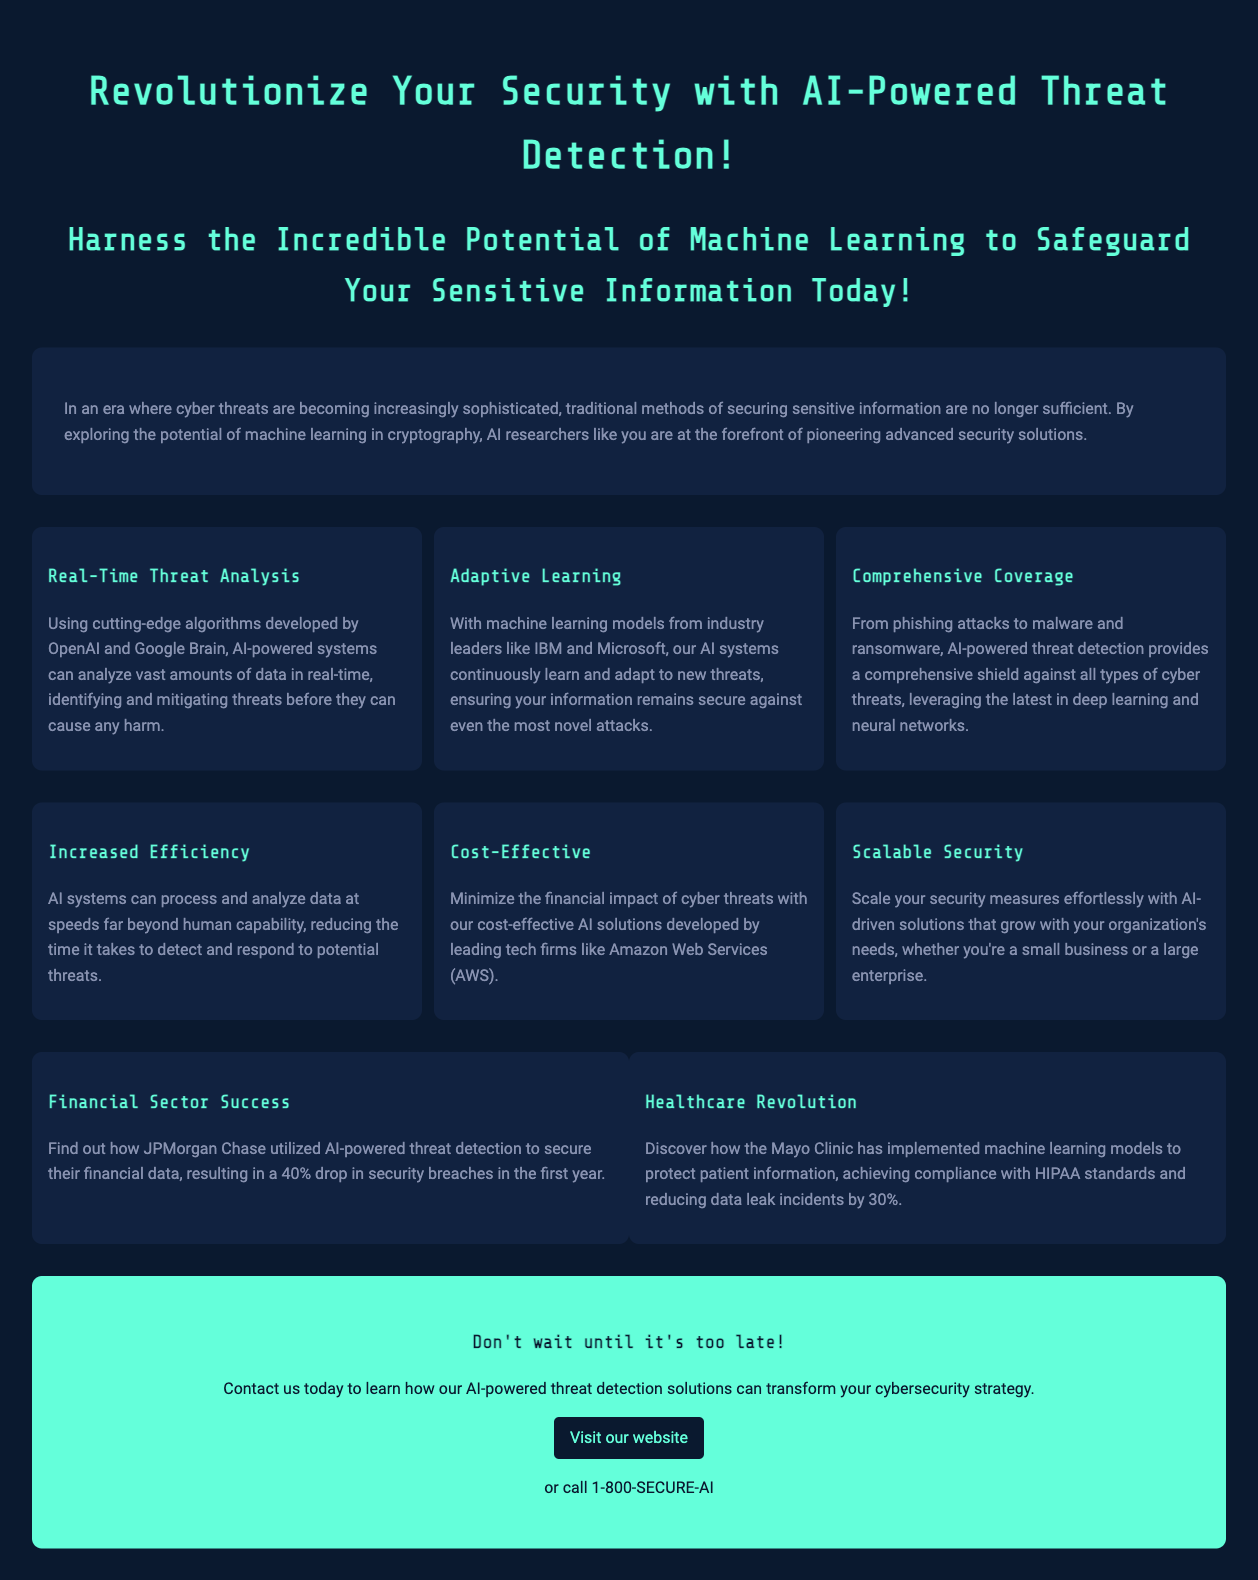What is the title of the document? The title is prominently displayed at the top of the document and introduces the main theme.
Answer: AI-Powered Threat Detection What type of systems does the document discuss? The introduction mentions the systems aimed at safeguarding sensitive information using advanced technologies.
Answer: AI-powered systems Which company is specifically mentioned as utilizing AI for threat detection in the financial sector? The case studies section provides specific examples of organizations using AI solutions for security.
Answer: JPMorgan Chase What percentage drop in security breaches did JPMorgan Chase achieve in the first year? This information is found in the case studies portion detailing the results of AI implementation.
Answer: 40% Which two companies are mentioned as developing cutting-edge algorithms? The features section lists companies that contribute to the development of AI algorithms for threat detection.
Answer: OpenAI and Google Brain What advantage does AI provide in terms of processing data? The benefits section highlights a key advantage of AI systems over human capabilities.
Answer: Speed How much did Mayo Clinic reduce data leak incidents by? This number is provided in the case studies section relating to the healthcare provider's use of AI.
Answer: 30% What is a key benefit mentioned for small businesses using AI solutions? The document identifies a specific advantage of adopting AI for various organizational sizes.
Answer: Scalable Security 